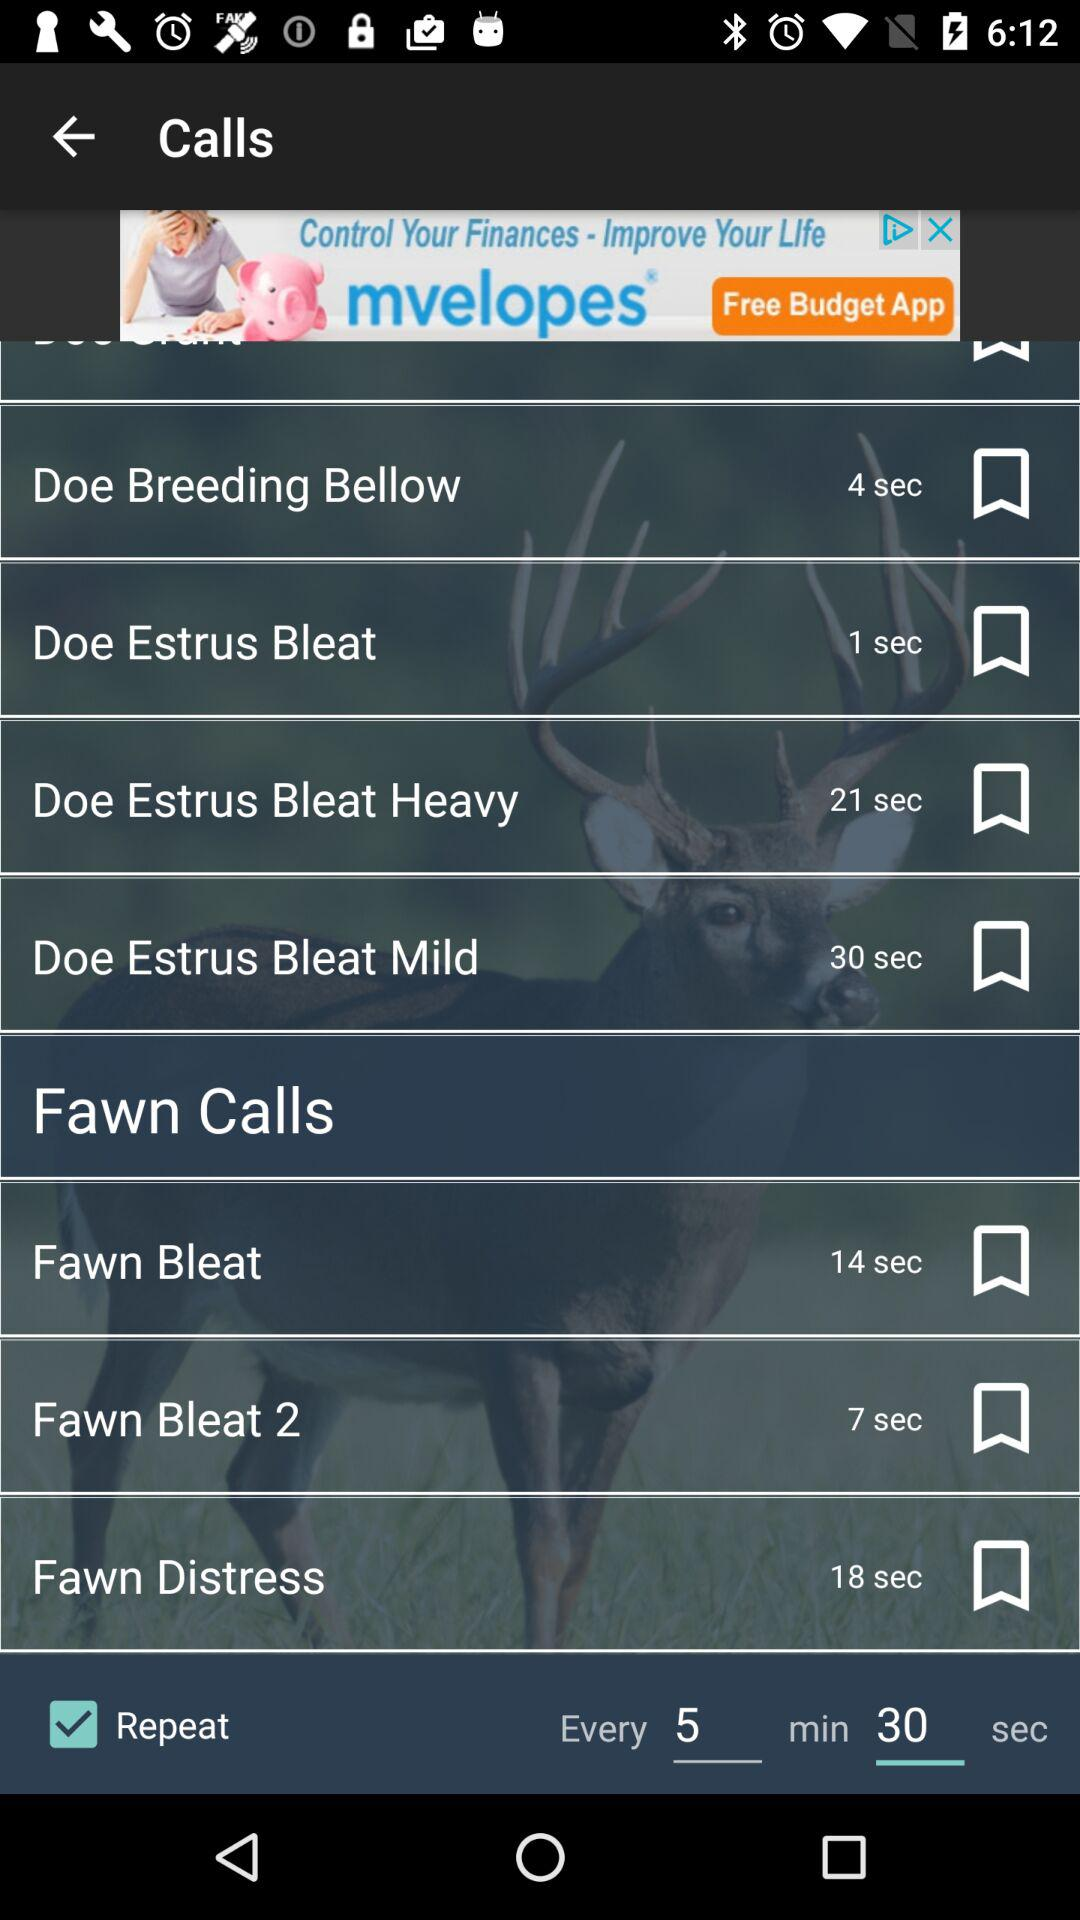How many seconds is the shortest call?
Answer the question using a single word or phrase. 1 